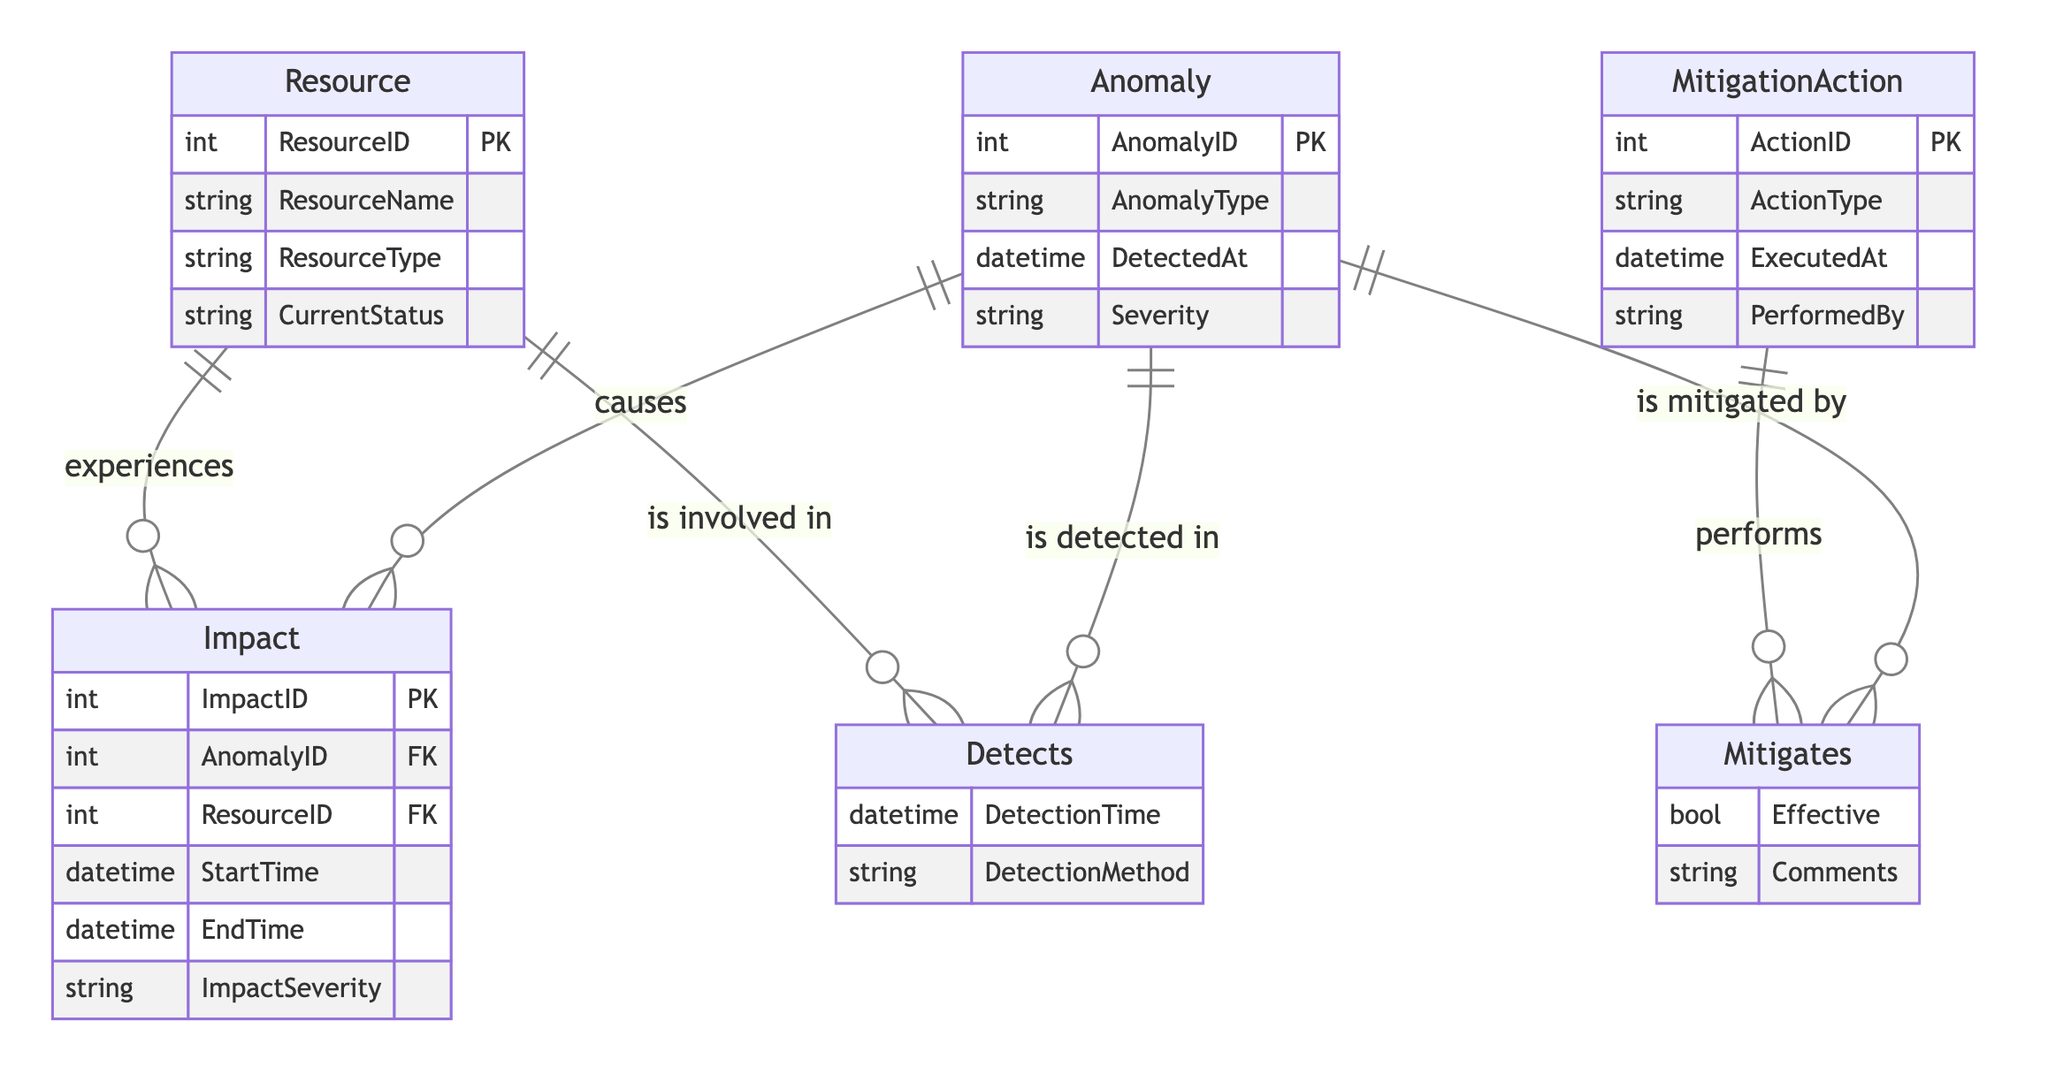What is the primary key of the Anomaly entity? The primary key of the Anomaly entity is specified in its attributes section as "AnomalyID (Primary Key)".
Answer: AnomalyID How many entities are there in the diagram? The entities listed are Anomaly, Resource, MitigationAction, and Impact, making a total of four entities in the diagram.
Answer: Four What type of relationship exists between Anomaly and Resource in the Detects relationship? The relationship between Anomaly and Resource in the Detects relationship is defined as Many-to-Many, indicating that multiple anomalies can be detected in multiple resources and vice versa.
Answer: Many-to-Many What is the foreign key in the Impact entity? The foreign keys in the Impact entity are "AnomalyID" and "ResourceID" which link this entity to both the Anomaly and Resource entities.
Answer: AnomalyID, ResourceID How many attributes does the MitigationAction entity have? The MitigationAction entity has four attributes: ActionID, ActionType, ExecutedAt, and PerformedBy, leading to a total of four attributes.
Answer: Four What does the relationship "Mitigates" indicate about the connection between MitigationAction and Anomaly? The relationship "Mitigates" indicates that one MitigationAction can mitigate multiple anomalies, indicating a One-to-Many relationship from MitigationAction to Anomaly.
Answer: One-to-Many During which event is the MitigationAction performed? The MitigationAction is performed at the event specified by the attribute "ExecutedAt".
Answer: ExecutedAt What is the cardinality of the relationship between Anomaly and Impact? The cardinality of the relationship between Anomaly and Impact is defined as One-to-Many, indicating that one anomaly can cause multiple impacts.
Answer: One-to-Many What attribute details the timing of the impact in the Impact entity? The Impact entity has "StartTime" and "EndTime" as attributes to detail the timing of the impact related to an anomaly affecting a resource.
Answer: StartTime, EndTime 